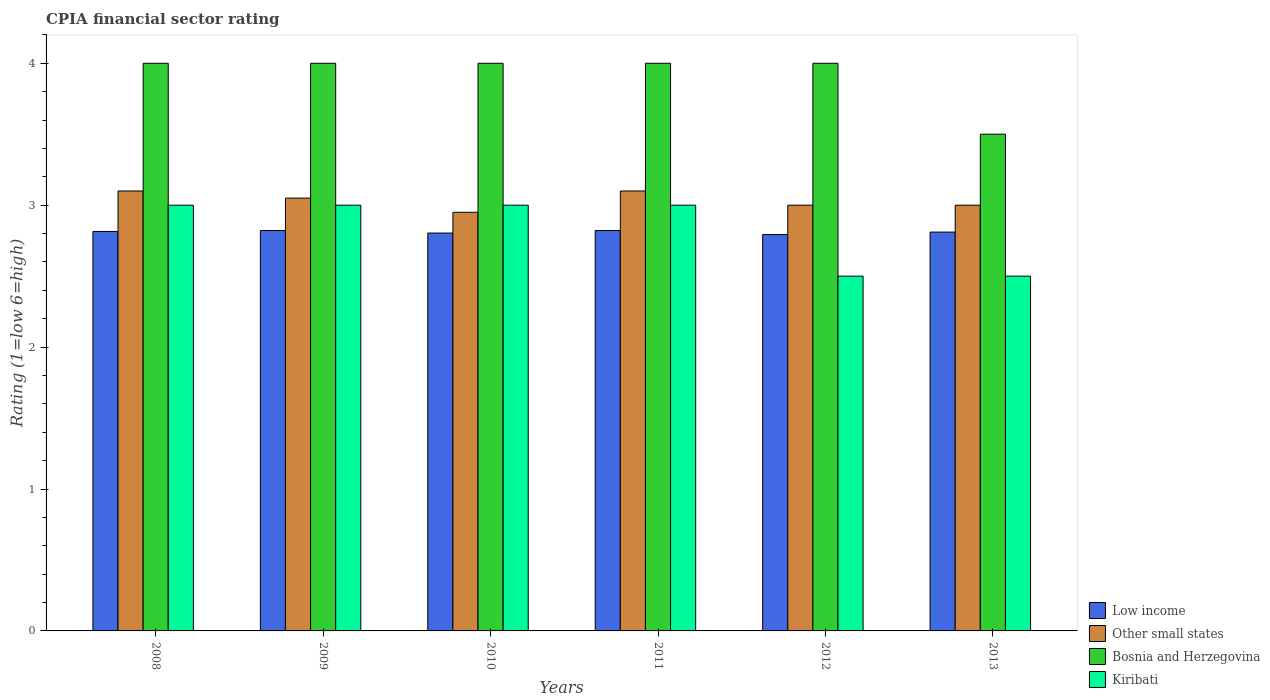How many groups of bars are there?
Make the answer very short. 6. What is the label of the 3rd group of bars from the left?
Provide a succinct answer. 2010. In how many cases, is the number of bars for a given year not equal to the number of legend labels?
Make the answer very short. 0. What is the CPIA rating in Low income in 2012?
Offer a very short reply. 2.79. Across all years, what is the maximum CPIA rating in Low income?
Your answer should be very brief. 2.82. Across all years, what is the minimum CPIA rating in Other small states?
Provide a short and direct response. 2.95. In which year was the CPIA rating in Other small states maximum?
Keep it short and to the point. 2008. What is the total CPIA rating in Other small states in the graph?
Offer a terse response. 18.2. What is the difference between the CPIA rating in Other small states in 2010 and that in 2013?
Give a very brief answer. -0.05. What is the difference between the CPIA rating in Other small states in 2008 and the CPIA rating in Low income in 2009?
Provide a short and direct response. 0.28. What is the average CPIA rating in Bosnia and Herzegovina per year?
Provide a short and direct response. 3.92. In the year 2008, what is the difference between the CPIA rating in Low income and CPIA rating in Kiribati?
Give a very brief answer. -0.19. What is the difference between the highest and the second highest CPIA rating in Other small states?
Your response must be concise. 0. What is the difference between the highest and the lowest CPIA rating in Kiribati?
Offer a very short reply. 0.5. In how many years, is the CPIA rating in Kiribati greater than the average CPIA rating in Kiribati taken over all years?
Offer a terse response. 4. What does the 3rd bar from the left in 2009 represents?
Offer a terse response. Bosnia and Herzegovina. What does the 2nd bar from the right in 2013 represents?
Give a very brief answer. Bosnia and Herzegovina. How many bars are there?
Provide a succinct answer. 24. Are all the bars in the graph horizontal?
Offer a very short reply. No. Does the graph contain any zero values?
Offer a terse response. No. How many legend labels are there?
Your answer should be compact. 4. How are the legend labels stacked?
Make the answer very short. Vertical. What is the title of the graph?
Your response must be concise. CPIA financial sector rating. Does "Somalia" appear as one of the legend labels in the graph?
Provide a short and direct response. No. What is the label or title of the Y-axis?
Keep it short and to the point. Rating (1=low 6=high). What is the Rating (1=low 6=high) in Low income in 2008?
Provide a short and direct response. 2.81. What is the Rating (1=low 6=high) in Other small states in 2008?
Make the answer very short. 3.1. What is the Rating (1=low 6=high) of Low income in 2009?
Make the answer very short. 2.82. What is the Rating (1=low 6=high) in Other small states in 2009?
Offer a very short reply. 3.05. What is the Rating (1=low 6=high) of Low income in 2010?
Provide a succinct answer. 2.8. What is the Rating (1=low 6=high) in Other small states in 2010?
Your response must be concise. 2.95. What is the Rating (1=low 6=high) in Kiribati in 2010?
Make the answer very short. 3. What is the Rating (1=low 6=high) of Low income in 2011?
Provide a short and direct response. 2.82. What is the Rating (1=low 6=high) in Other small states in 2011?
Your answer should be compact. 3.1. What is the Rating (1=low 6=high) of Bosnia and Herzegovina in 2011?
Your answer should be very brief. 4. What is the Rating (1=low 6=high) in Low income in 2012?
Offer a terse response. 2.79. What is the Rating (1=low 6=high) of Other small states in 2012?
Ensure brevity in your answer.  3. What is the Rating (1=low 6=high) of Bosnia and Herzegovina in 2012?
Provide a succinct answer. 4. What is the Rating (1=low 6=high) of Kiribati in 2012?
Offer a very short reply. 2.5. What is the Rating (1=low 6=high) of Low income in 2013?
Offer a very short reply. 2.81. What is the Rating (1=low 6=high) in Other small states in 2013?
Make the answer very short. 3. What is the Rating (1=low 6=high) in Bosnia and Herzegovina in 2013?
Provide a short and direct response. 3.5. Across all years, what is the maximum Rating (1=low 6=high) of Low income?
Your answer should be very brief. 2.82. Across all years, what is the maximum Rating (1=low 6=high) of Other small states?
Offer a terse response. 3.1. Across all years, what is the maximum Rating (1=low 6=high) of Kiribati?
Your answer should be very brief. 3. Across all years, what is the minimum Rating (1=low 6=high) of Low income?
Your answer should be very brief. 2.79. Across all years, what is the minimum Rating (1=low 6=high) of Other small states?
Your answer should be very brief. 2.95. Across all years, what is the minimum Rating (1=low 6=high) of Kiribati?
Offer a terse response. 2.5. What is the total Rating (1=low 6=high) in Low income in the graph?
Ensure brevity in your answer.  16.86. What is the total Rating (1=low 6=high) of Other small states in the graph?
Give a very brief answer. 18.2. What is the total Rating (1=low 6=high) of Bosnia and Herzegovina in the graph?
Make the answer very short. 23.5. What is the total Rating (1=low 6=high) of Kiribati in the graph?
Your answer should be very brief. 17. What is the difference between the Rating (1=low 6=high) in Low income in 2008 and that in 2009?
Provide a short and direct response. -0.01. What is the difference between the Rating (1=low 6=high) in Kiribati in 2008 and that in 2009?
Your answer should be very brief. 0. What is the difference between the Rating (1=low 6=high) in Low income in 2008 and that in 2010?
Your response must be concise. 0.01. What is the difference between the Rating (1=low 6=high) of Other small states in 2008 and that in 2010?
Your response must be concise. 0.15. What is the difference between the Rating (1=low 6=high) in Bosnia and Herzegovina in 2008 and that in 2010?
Make the answer very short. 0. What is the difference between the Rating (1=low 6=high) in Kiribati in 2008 and that in 2010?
Provide a short and direct response. 0. What is the difference between the Rating (1=low 6=high) in Low income in 2008 and that in 2011?
Make the answer very short. -0.01. What is the difference between the Rating (1=low 6=high) in Low income in 2008 and that in 2012?
Make the answer very short. 0.02. What is the difference between the Rating (1=low 6=high) of Bosnia and Herzegovina in 2008 and that in 2012?
Provide a succinct answer. 0. What is the difference between the Rating (1=low 6=high) in Low income in 2008 and that in 2013?
Offer a very short reply. 0. What is the difference between the Rating (1=low 6=high) in Low income in 2009 and that in 2010?
Make the answer very short. 0.02. What is the difference between the Rating (1=low 6=high) in Other small states in 2009 and that in 2011?
Your response must be concise. -0.05. What is the difference between the Rating (1=low 6=high) in Low income in 2009 and that in 2012?
Give a very brief answer. 0.03. What is the difference between the Rating (1=low 6=high) of Other small states in 2009 and that in 2012?
Provide a short and direct response. 0.05. What is the difference between the Rating (1=low 6=high) of Bosnia and Herzegovina in 2009 and that in 2012?
Ensure brevity in your answer.  0. What is the difference between the Rating (1=low 6=high) in Kiribati in 2009 and that in 2012?
Give a very brief answer. 0.5. What is the difference between the Rating (1=low 6=high) in Low income in 2009 and that in 2013?
Your answer should be very brief. 0.01. What is the difference between the Rating (1=low 6=high) of Other small states in 2009 and that in 2013?
Ensure brevity in your answer.  0.05. What is the difference between the Rating (1=low 6=high) of Kiribati in 2009 and that in 2013?
Provide a succinct answer. 0.5. What is the difference between the Rating (1=low 6=high) of Low income in 2010 and that in 2011?
Your answer should be compact. -0.02. What is the difference between the Rating (1=low 6=high) in Low income in 2010 and that in 2012?
Offer a very short reply. 0.01. What is the difference between the Rating (1=low 6=high) of Kiribati in 2010 and that in 2012?
Your response must be concise. 0.5. What is the difference between the Rating (1=low 6=high) of Low income in 2010 and that in 2013?
Your response must be concise. -0.01. What is the difference between the Rating (1=low 6=high) in Low income in 2011 and that in 2012?
Keep it short and to the point. 0.03. What is the difference between the Rating (1=low 6=high) of Other small states in 2011 and that in 2012?
Make the answer very short. 0.1. What is the difference between the Rating (1=low 6=high) in Bosnia and Herzegovina in 2011 and that in 2012?
Make the answer very short. 0. What is the difference between the Rating (1=low 6=high) of Kiribati in 2011 and that in 2012?
Provide a succinct answer. 0.5. What is the difference between the Rating (1=low 6=high) of Low income in 2011 and that in 2013?
Offer a very short reply. 0.01. What is the difference between the Rating (1=low 6=high) in Low income in 2012 and that in 2013?
Provide a short and direct response. -0.02. What is the difference between the Rating (1=low 6=high) of Bosnia and Herzegovina in 2012 and that in 2013?
Your response must be concise. 0.5. What is the difference between the Rating (1=low 6=high) in Low income in 2008 and the Rating (1=low 6=high) in Other small states in 2009?
Provide a short and direct response. -0.24. What is the difference between the Rating (1=low 6=high) of Low income in 2008 and the Rating (1=low 6=high) of Bosnia and Herzegovina in 2009?
Ensure brevity in your answer.  -1.19. What is the difference between the Rating (1=low 6=high) in Low income in 2008 and the Rating (1=low 6=high) in Kiribati in 2009?
Provide a short and direct response. -0.19. What is the difference between the Rating (1=low 6=high) of Bosnia and Herzegovina in 2008 and the Rating (1=low 6=high) of Kiribati in 2009?
Provide a succinct answer. 1. What is the difference between the Rating (1=low 6=high) of Low income in 2008 and the Rating (1=low 6=high) of Other small states in 2010?
Keep it short and to the point. -0.14. What is the difference between the Rating (1=low 6=high) in Low income in 2008 and the Rating (1=low 6=high) in Bosnia and Herzegovina in 2010?
Keep it short and to the point. -1.19. What is the difference between the Rating (1=low 6=high) in Low income in 2008 and the Rating (1=low 6=high) in Kiribati in 2010?
Your answer should be compact. -0.19. What is the difference between the Rating (1=low 6=high) in Other small states in 2008 and the Rating (1=low 6=high) in Bosnia and Herzegovina in 2010?
Your response must be concise. -0.9. What is the difference between the Rating (1=low 6=high) in Other small states in 2008 and the Rating (1=low 6=high) in Kiribati in 2010?
Ensure brevity in your answer.  0.1. What is the difference between the Rating (1=low 6=high) in Bosnia and Herzegovina in 2008 and the Rating (1=low 6=high) in Kiribati in 2010?
Offer a very short reply. 1. What is the difference between the Rating (1=low 6=high) of Low income in 2008 and the Rating (1=low 6=high) of Other small states in 2011?
Provide a succinct answer. -0.29. What is the difference between the Rating (1=low 6=high) in Low income in 2008 and the Rating (1=low 6=high) in Bosnia and Herzegovina in 2011?
Offer a terse response. -1.19. What is the difference between the Rating (1=low 6=high) of Low income in 2008 and the Rating (1=low 6=high) of Kiribati in 2011?
Keep it short and to the point. -0.19. What is the difference between the Rating (1=low 6=high) in Other small states in 2008 and the Rating (1=low 6=high) in Kiribati in 2011?
Make the answer very short. 0.1. What is the difference between the Rating (1=low 6=high) in Low income in 2008 and the Rating (1=low 6=high) in Other small states in 2012?
Give a very brief answer. -0.19. What is the difference between the Rating (1=low 6=high) of Low income in 2008 and the Rating (1=low 6=high) of Bosnia and Herzegovina in 2012?
Give a very brief answer. -1.19. What is the difference between the Rating (1=low 6=high) of Low income in 2008 and the Rating (1=low 6=high) of Kiribati in 2012?
Offer a very short reply. 0.31. What is the difference between the Rating (1=low 6=high) in Other small states in 2008 and the Rating (1=low 6=high) in Kiribati in 2012?
Keep it short and to the point. 0.6. What is the difference between the Rating (1=low 6=high) of Low income in 2008 and the Rating (1=low 6=high) of Other small states in 2013?
Offer a terse response. -0.19. What is the difference between the Rating (1=low 6=high) of Low income in 2008 and the Rating (1=low 6=high) of Bosnia and Herzegovina in 2013?
Offer a very short reply. -0.69. What is the difference between the Rating (1=low 6=high) in Low income in 2008 and the Rating (1=low 6=high) in Kiribati in 2013?
Offer a very short reply. 0.31. What is the difference between the Rating (1=low 6=high) in Other small states in 2008 and the Rating (1=low 6=high) in Bosnia and Herzegovina in 2013?
Provide a short and direct response. -0.4. What is the difference between the Rating (1=low 6=high) of Low income in 2009 and the Rating (1=low 6=high) of Other small states in 2010?
Provide a short and direct response. -0.13. What is the difference between the Rating (1=low 6=high) in Low income in 2009 and the Rating (1=low 6=high) in Bosnia and Herzegovina in 2010?
Make the answer very short. -1.18. What is the difference between the Rating (1=low 6=high) of Low income in 2009 and the Rating (1=low 6=high) of Kiribati in 2010?
Provide a short and direct response. -0.18. What is the difference between the Rating (1=low 6=high) in Other small states in 2009 and the Rating (1=low 6=high) in Bosnia and Herzegovina in 2010?
Make the answer very short. -0.95. What is the difference between the Rating (1=low 6=high) of Low income in 2009 and the Rating (1=low 6=high) of Other small states in 2011?
Your answer should be very brief. -0.28. What is the difference between the Rating (1=low 6=high) in Low income in 2009 and the Rating (1=low 6=high) in Bosnia and Herzegovina in 2011?
Provide a short and direct response. -1.18. What is the difference between the Rating (1=low 6=high) of Low income in 2009 and the Rating (1=low 6=high) of Kiribati in 2011?
Offer a very short reply. -0.18. What is the difference between the Rating (1=low 6=high) in Other small states in 2009 and the Rating (1=low 6=high) in Bosnia and Herzegovina in 2011?
Your answer should be compact. -0.95. What is the difference between the Rating (1=low 6=high) of Bosnia and Herzegovina in 2009 and the Rating (1=low 6=high) of Kiribati in 2011?
Your answer should be very brief. 1. What is the difference between the Rating (1=low 6=high) in Low income in 2009 and the Rating (1=low 6=high) in Other small states in 2012?
Keep it short and to the point. -0.18. What is the difference between the Rating (1=low 6=high) of Low income in 2009 and the Rating (1=low 6=high) of Bosnia and Herzegovina in 2012?
Provide a succinct answer. -1.18. What is the difference between the Rating (1=low 6=high) in Low income in 2009 and the Rating (1=low 6=high) in Kiribati in 2012?
Ensure brevity in your answer.  0.32. What is the difference between the Rating (1=low 6=high) of Other small states in 2009 and the Rating (1=low 6=high) of Bosnia and Herzegovina in 2012?
Provide a succinct answer. -0.95. What is the difference between the Rating (1=low 6=high) of Other small states in 2009 and the Rating (1=low 6=high) of Kiribati in 2012?
Provide a succinct answer. 0.55. What is the difference between the Rating (1=low 6=high) in Bosnia and Herzegovina in 2009 and the Rating (1=low 6=high) in Kiribati in 2012?
Keep it short and to the point. 1.5. What is the difference between the Rating (1=low 6=high) in Low income in 2009 and the Rating (1=low 6=high) in Other small states in 2013?
Your answer should be very brief. -0.18. What is the difference between the Rating (1=low 6=high) in Low income in 2009 and the Rating (1=low 6=high) in Bosnia and Herzegovina in 2013?
Your answer should be compact. -0.68. What is the difference between the Rating (1=low 6=high) of Low income in 2009 and the Rating (1=low 6=high) of Kiribati in 2013?
Your answer should be very brief. 0.32. What is the difference between the Rating (1=low 6=high) in Other small states in 2009 and the Rating (1=low 6=high) in Bosnia and Herzegovina in 2013?
Your response must be concise. -0.45. What is the difference between the Rating (1=low 6=high) in Other small states in 2009 and the Rating (1=low 6=high) in Kiribati in 2013?
Provide a succinct answer. 0.55. What is the difference between the Rating (1=low 6=high) of Bosnia and Herzegovina in 2009 and the Rating (1=low 6=high) of Kiribati in 2013?
Keep it short and to the point. 1.5. What is the difference between the Rating (1=low 6=high) of Low income in 2010 and the Rating (1=low 6=high) of Other small states in 2011?
Provide a short and direct response. -0.3. What is the difference between the Rating (1=low 6=high) of Low income in 2010 and the Rating (1=low 6=high) of Bosnia and Herzegovina in 2011?
Offer a terse response. -1.2. What is the difference between the Rating (1=low 6=high) in Low income in 2010 and the Rating (1=low 6=high) in Kiribati in 2011?
Offer a very short reply. -0.2. What is the difference between the Rating (1=low 6=high) of Other small states in 2010 and the Rating (1=low 6=high) of Bosnia and Herzegovina in 2011?
Offer a terse response. -1.05. What is the difference between the Rating (1=low 6=high) of Other small states in 2010 and the Rating (1=low 6=high) of Kiribati in 2011?
Your answer should be compact. -0.05. What is the difference between the Rating (1=low 6=high) in Low income in 2010 and the Rating (1=low 6=high) in Other small states in 2012?
Your response must be concise. -0.2. What is the difference between the Rating (1=low 6=high) in Low income in 2010 and the Rating (1=low 6=high) in Bosnia and Herzegovina in 2012?
Ensure brevity in your answer.  -1.2. What is the difference between the Rating (1=low 6=high) of Low income in 2010 and the Rating (1=low 6=high) of Kiribati in 2012?
Keep it short and to the point. 0.3. What is the difference between the Rating (1=low 6=high) in Other small states in 2010 and the Rating (1=low 6=high) in Bosnia and Herzegovina in 2012?
Give a very brief answer. -1.05. What is the difference between the Rating (1=low 6=high) in Other small states in 2010 and the Rating (1=low 6=high) in Kiribati in 2012?
Your answer should be compact. 0.45. What is the difference between the Rating (1=low 6=high) of Bosnia and Herzegovina in 2010 and the Rating (1=low 6=high) of Kiribati in 2012?
Make the answer very short. 1.5. What is the difference between the Rating (1=low 6=high) of Low income in 2010 and the Rating (1=low 6=high) of Other small states in 2013?
Offer a terse response. -0.2. What is the difference between the Rating (1=low 6=high) of Low income in 2010 and the Rating (1=low 6=high) of Bosnia and Herzegovina in 2013?
Provide a short and direct response. -0.7. What is the difference between the Rating (1=low 6=high) of Low income in 2010 and the Rating (1=low 6=high) of Kiribati in 2013?
Your response must be concise. 0.3. What is the difference between the Rating (1=low 6=high) of Other small states in 2010 and the Rating (1=low 6=high) of Bosnia and Herzegovina in 2013?
Give a very brief answer. -0.55. What is the difference between the Rating (1=low 6=high) in Other small states in 2010 and the Rating (1=low 6=high) in Kiribati in 2013?
Give a very brief answer. 0.45. What is the difference between the Rating (1=low 6=high) in Low income in 2011 and the Rating (1=low 6=high) in Other small states in 2012?
Your answer should be very brief. -0.18. What is the difference between the Rating (1=low 6=high) of Low income in 2011 and the Rating (1=low 6=high) of Bosnia and Herzegovina in 2012?
Your response must be concise. -1.18. What is the difference between the Rating (1=low 6=high) of Low income in 2011 and the Rating (1=low 6=high) of Kiribati in 2012?
Your answer should be compact. 0.32. What is the difference between the Rating (1=low 6=high) in Other small states in 2011 and the Rating (1=low 6=high) in Bosnia and Herzegovina in 2012?
Your answer should be very brief. -0.9. What is the difference between the Rating (1=low 6=high) in Other small states in 2011 and the Rating (1=low 6=high) in Kiribati in 2012?
Give a very brief answer. 0.6. What is the difference between the Rating (1=low 6=high) of Bosnia and Herzegovina in 2011 and the Rating (1=low 6=high) of Kiribati in 2012?
Offer a terse response. 1.5. What is the difference between the Rating (1=low 6=high) of Low income in 2011 and the Rating (1=low 6=high) of Other small states in 2013?
Your answer should be compact. -0.18. What is the difference between the Rating (1=low 6=high) of Low income in 2011 and the Rating (1=low 6=high) of Bosnia and Herzegovina in 2013?
Provide a short and direct response. -0.68. What is the difference between the Rating (1=low 6=high) of Low income in 2011 and the Rating (1=low 6=high) of Kiribati in 2013?
Your answer should be compact. 0.32. What is the difference between the Rating (1=low 6=high) in Other small states in 2011 and the Rating (1=low 6=high) in Kiribati in 2013?
Your response must be concise. 0.6. What is the difference between the Rating (1=low 6=high) in Low income in 2012 and the Rating (1=low 6=high) in Other small states in 2013?
Make the answer very short. -0.21. What is the difference between the Rating (1=low 6=high) in Low income in 2012 and the Rating (1=low 6=high) in Bosnia and Herzegovina in 2013?
Your answer should be very brief. -0.71. What is the difference between the Rating (1=low 6=high) in Low income in 2012 and the Rating (1=low 6=high) in Kiribati in 2013?
Offer a terse response. 0.29. What is the difference between the Rating (1=low 6=high) of Other small states in 2012 and the Rating (1=low 6=high) of Kiribati in 2013?
Offer a terse response. 0.5. What is the average Rating (1=low 6=high) of Low income per year?
Provide a succinct answer. 2.81. What is the average Rating (1=low 6=high) in Other small states per year?
Give a very brief answer. 3.03. What is the average Rating (1=low 6=high) in Bosnia and Herzegovina per year?
Give a very brief answer. 3.92. What is the average Rating (1=low 6=high) in Kiribati per year?
Give a very brief answer. 2.83. In the year 2008, what is the difference between the Rating (1=low 6=high) of Low income and Rating (1=low 6=high) of Other small states?
Give a very brief answer. -0.29. In the year 2008, what is the difference between the Rating (1=low 6=high) in Low income and Rating (1=low 6=high) in Bosnia and Herzegovina?
Give a very brief answer. -1.19. In the year 2008, what is the difference between the Rating (1=low 6=high) in Low income and Rating (1=low 6=high) in Kiribati?
Make the answer very short. -0.19. In the year 2008, what is the difference between the Rating (1=low 6=high) in Other small states and Rating (1=low 6=high) in Bosnia and Herzegovina?
Make the answer very short. -0.9. In the year 2008, what is the difference between the Rating (1=low 6=high) in Bosnia and Herzegovina and Rating (1=low 6=high) in Kiribati?
Provide a short and direct response. 1. In the year 2009, what is the difference between the Rating (1=low 6=high) of Low income and Rating (1=low 6=high) of Other small states?
Make the answer very short. -0.23. In the year 2009, what is the difference between the Rating (1=low 6=high) of Low income and Rating (1=low 6=high) of Bosnia and Herzegovina?
Make the answer very short. -1.18. In the year 2009, what is the difference between the Rating (1=low 6=high) in Low income and Rating (1=low 6=high) in Kiribati?
Offer a very short reply. -0.18. In the year 2009, what is the difference between the Rating (1=low 6=high) in Other small states and Rating (1=low 6=high) in Bosnia and Herzegovina?
Offer a terse response. -0.95. In the year 2010, what is the difference between the Rating (1=low 6=high) in Low income and Rating (1=low 6=high) in Other small states?
Provide a short and direct response. -0.15. In the year 2010, what is the difference between the Rating (1=low 6=high) of Low income and Rating (1=low 6=high) of Bosnia and Herzegovina?
Keep it short and to the point. -1.2. In the year 2010, what is the difference between the Rating (1=low 6=high) of Low income and Rating (1=low 6=high) of Kiribati?
Give a very brief answer. -0.2. In the year 2010, what is the difference between the Rating (1=low 6=high) of Other small states and Rating (1=low 6=high) of Bosnia and Herzegovina?
Keep it short and to the point. -1.05. In the year 2011, what is the difference between the Rating (1=low 6=high) of Low income and Rating (1=low 6=high) of Other small states?
Your response must be concise. -0.28. In the year 2011, what is the difference between the Rating (1=low 6=high) of Low income and Rating (1=low 6=high) of Bosnia and Herzegovina?
Provide a short and direct response. -1.18. In the year 2011, what is the difference between the Rating (1=low 6=high) in Low income and Rating (1=low 6=high) in Kiribati?
Your response must be concise. -0.18. In the year 2011, what is the difference between the Rating (1=low 6=high) in Other small states and Rating (1=low 6=high) in Kiribati?
Offer a terse response. 0.1. In the year 2012, what is the difference between the Rating (1=low 6=high) of Low income and Rating (1=low 6=high) of Other small states?
Your answer should be compact. -0.21. In the year 2012, what is the difference between the Rating (1=low 6=high) of Low income and Rating (1=low 6=high) of Bosnia and Herzegovina?
Your answer should be very brief. -1.21. In the year 2012, what is the difference between the Rating (1=low 6=high) in Low income and Rating (1=low 6=high) in Kiribati?
Keep it short and to the point. 0.29. In the year 2012, what is the difference between the Rating (1=low 6=high) of Bosnia and Herzegovina and Rating (1=low 6=high) of Kiribati?
Keep it short and to the point. 1.5. In the year 2013, what is the difference between the Rating (1=low 6=high) of Low income and Rating (1=low 6=high) of Other small states?
Your response must be concise. -0.19. In the year 2013, what is the difference between the Rating (1=low 6=high) of Low income and Rating (1=low 6=high) of Bosnia and Herzegovina?
Offer a very short reply. -0.69. In the year 2013, what is the difference between the Rating (1=low 6=high) in Low income and Rating (1=low 6=high) in Kiribati?
Your answer should be compact. 0.31. In the year 2013, what is the difference between the Rating (1=low 6=high) in Other small states and Rating (1=low 6=high) in Bosnia and Herzegovina?
Provide a succinct answer. -0.5. In the year 2013, what is the difference between the Rating (1=low 6=high) in Bosnia and Herzegovina and Rating (1=low 6=high) in Kiribati?
Offer a very short reply. 1. What is the ratio of the Rating (1=low 6=high) in Other small states in 2008 to that in 2009?
Give a very brief answer. 1.02. What is the ratio of the Rating (1=low 6=high) in Bosnia and Herzegovina in 2008 to that in 2009?
Your response must be concise. 1. What is the ratio of the Rating (1=low 6=high) in Kiribati in 2008 to that in 2009?
Ensure brevity in your answer.  1. What is the ratio of the Rating (1=low 6=high) of Other small states in 2008 to that in 2010?
Your answer should be compact. 1.05. What is the ratio of the Rating (1=low 6=high) in Bosnia and Herzegovina in 2008 to that in 2010?
Offer a terse response. 1. What is the ratio of the Rating (1=low 6=high) in Bosnia and Herzegovina in 2008 to that in 2011?
Provide a short and direct response. 1. What is the ratio of the Rating (1=low 6=high) of Low income in 2008 to that in 2012?
Ensure brevity in your answer.  1.01. What is the ratio of the Rating (1=low 6=high) in Other small states in 2008 to that in 2012?
Make the answer very short. 1.03. What is the ratio of the Rating (1=low 6=high) of Low income in 2008 to that in 2013?
Offer a terse response. 1. What is the ratio of the Rating (1=low 6=high) of Other small states in 2008 to that in 2013?
Offer a terse response. 1.03. What is the ratio of the Rating (1=low 6=high) in Bosnia and Herzegovina in 2008 to that in 2013?
Your answer should be compact. 1.14. What is the ratio of the Rating (1=low 6=high) in Low income in 2009 to that in 2010?
Offer a terse response. 1.01. What is the ratio of the Rating (1=low 6=high) in Other small states in 2009 to that in 2010?
Offer a terse response. 1.03. What is the ratio of the Rating (1=low 6=high) in Low income in 2009 to that in 2011?
Make the answer very short. 1. What is the ratio of the Rating (1=low 6=high) of Other small states in 2009 to that in 2011?
Your answer should be very brief. 0.98. What is the ratio of the Rating (1=low 6=high) of Bosnia and Herzegovina in 2009 to that in 2011?
Give a very brief answer. 1. What is the ratio of the Rating (1=low 6=high) in Kiribati in 2009 to that in 2011?
Offer a terse response. 1. What is the ratio of the Rating (1=low 6=high) of Low income in 2009 to that in 2012?
Make the answer very short. 1.01. What is the ratio of the Rating (1=low 6=high) in Other small states in 2009 to that in 2012?
Provide a short and direct response. 1.02. What is the ratio of the Rating (1=low 6=high) of Low income in 2009 to that in 2013?
Give a very brief answer. 1. What is the ratio of the Rating (1=low 6=high) of Other small states in 2009 to that in 2013?
Make the answer very short. 1.02. What is the ratio of the Rating (1=low 6=high) of Bosnia and Herzegovina in 2009 to that in 2013?
Offer a very short reply. 1.14. What is the ratio of the Rating (1=low 6=high) of Other small states in 2010 to that in 2011?
Your answer should be very brief. 0.95. What is the ratio of the Rating (1=low 6=high) in Bosnia and Herzegovina in 2010 to that in 2011?
Your response must be concise. 1. What is the ratio of the Rating (1=low 6=high) of Kiribati in 2010 to that in 2011?
Offer a terse response. 1. What is the ratio of the Rating (1=low 6=high) of Other small states in 2010 to that in 2012?
Your answer should be very brief. 0.98. What is the ratio of the Rating (1=low 6=high) in Kiribati in 2010 to that in 2012?
Offer a very short reply. 1.2. What is the ratio of the Rating (1=low 6=high) in Low income in 2010 to that in 2013?
Give a very brief answer. 1. What is the ratio of the Rating (1=low 6=high) in Other small states in 2010 to that in 2013?
Offer a terse response. 0.98. What is the ratio of the Rating (1=low 6=high) of Kiribati in 2011 to that in 2012?
Your answer should be very brief. 1.2. What is the ratio of the Rating (1=low 6=high) of Low income in 2011 to that in 2013?
Give a very brief answer. 1. What is the ratio of the Rating (1=low 6=high) of Low income in 2012 to that in 2013?
Your answer should be compact. 0.99. What is the ratio of the Rating (1=low 6=high) of Other small states in 2012 to that in 2013?
Keep it short and to the point. 1. What is the ratio of the Rating (1=low 6=high) of Kiribati in 2012 to that in 2013?
Keep it short and to the point. 1. What is the difference between the highest and the second highest Rating (1=low 6=high) of Bosnia and Herzegovina?
Your answer should be compact. 0. What is the difference between the highest and the second highest Rating (1=low 6=high) in Kiribati?
Provide a succinct answer. 0. What is the difference between the highest and the lowest Rating (1=low 6=high) in Low income?
Keep it short and to the point. 0.03. What is the difference between the highest and the lowest Rating (1=low 6=high) in Other small states?
Your response must be concise. 0.15. 